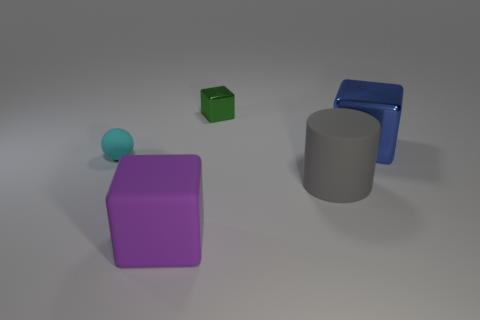There is a metallic cube on the left side of the big cylinder; what number of gray cylinders are behind it?
Offer a very short reply. 0. What color is the rubber ball that is the same size as the green metal block?
Keep it short and to the point. Cyan. Is there another large matte object of the same shape as the blue object?
Your response must be concise. Yes. Are there fewer green metallic objects than blocks?
Offer a very short reply. Yes. There is a large block behind the purple rubber cube; what is its color?
Offer a very short reply. Blue. What shape is the big rubber thing behind the big object that is in front of the large cylinder?
Give a very brief answer. Cylinder. Are the small cube and the block that is in front of the blue block made of the same material?
Provide a short and direct response. No. How many blue blocks have the same size as the blue shiny thing?
Keep it short and to the point. 0. Is the number of big gray cylinders to the left of the green metal object less than the number of small cyan rubber objects?
Your answer should be compact. Yes. There is a cyan rubber ball; how many matte objects are on the right side of it?
Provide a succinct answer. 2. 